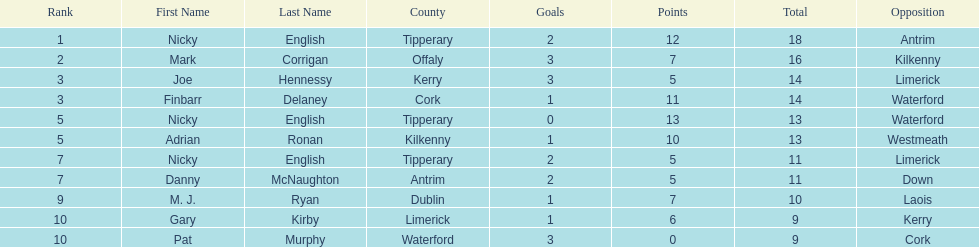What was the combined total of nicky english and mark corrigan? 34. 